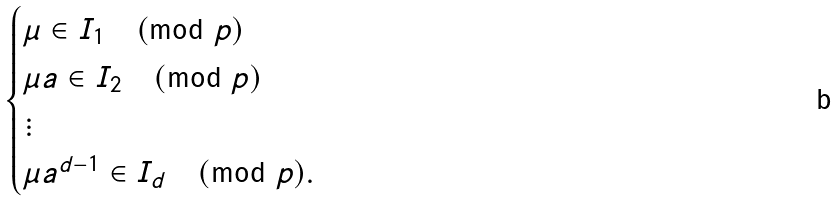Convert formula to latex. <formula><loc_0><loc_0><loc_500><loc_500>\begin{cases} \mu \in I _ { 1 } \pmod { p } \\ \mu a \in I _ { 2 } \pmod { p } \\ \vdots \\ \mu a ^ { d - 1 } \in I _ { d } \pmod { p } . \end{cases}</formula> 